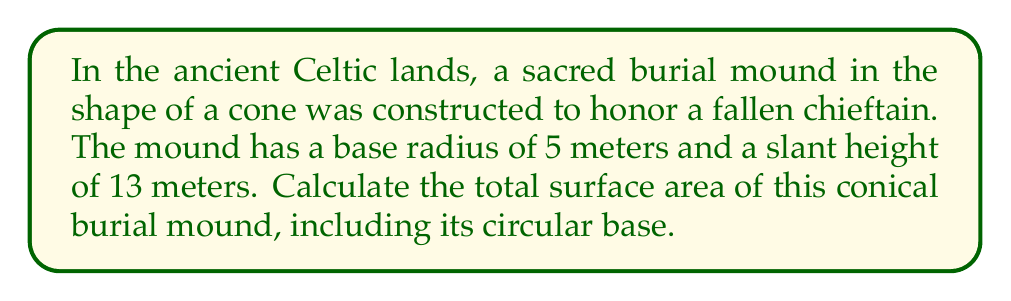What is the answer to this math problem? To solve this problem, we need to calculate the surface area of a cone, which consists of the lateral surface area (the curved surface) and the area of the circular base.

1. Let's define our variables:
   $r$ = radius of the base = 5 meters
   $s$ = slant height = 13 meters

2. The formula for the lateral surface area of a cone is:
   $$A_{lateral} = \pi rs$$

3. The formula for the area of the circular base is:
   $$A_{base} = \pi r^2$$

4. The total surface area is the sum of these two:
   $$A_{total} = A_{lateral} + A_{base} = \pi rs + \pi r^2 = \pi r(s + r)$$

5. Now, let's substitute our values:
   $$A_{total} = \pi \cdot 5 \cdot (13 + 5) = 5\pi \cdot 18 = 90\pi$$

6. To get the final answer in square meters:
   $$A_{total} = 90\pi \approx 282.74 \text{ m}^2$$

[asy]
import geometry;

size(200);
pair O=(0,0), A=(5,0), B=(0,12);
draw(O--A--B--cycle);
draw(Arc(O,A,180));
label("5 m",O--A,S);
label("13 m",A--B,NE);
label("r",O--A/2,N);
label("s",A--B/2,SE);
[/asy]
Answer: The total surface area of the conical Celtic burial mound is approximately $282.74 \text{ m}^2$. 